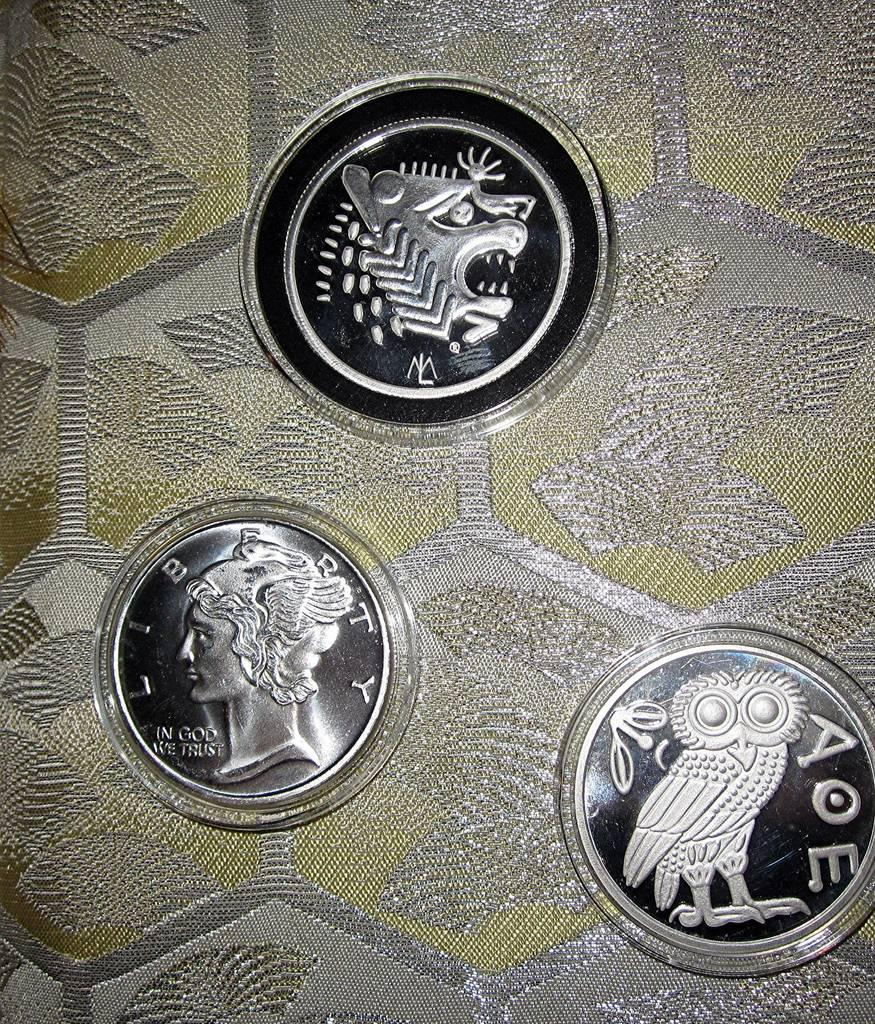What objects are present in the image? There are coins in the image. Where are the coins located? The coins are on a table. How many fingers are visible on the coins in the image? There are no fingers visible on the coins in the image, as coins do not have fingers. 